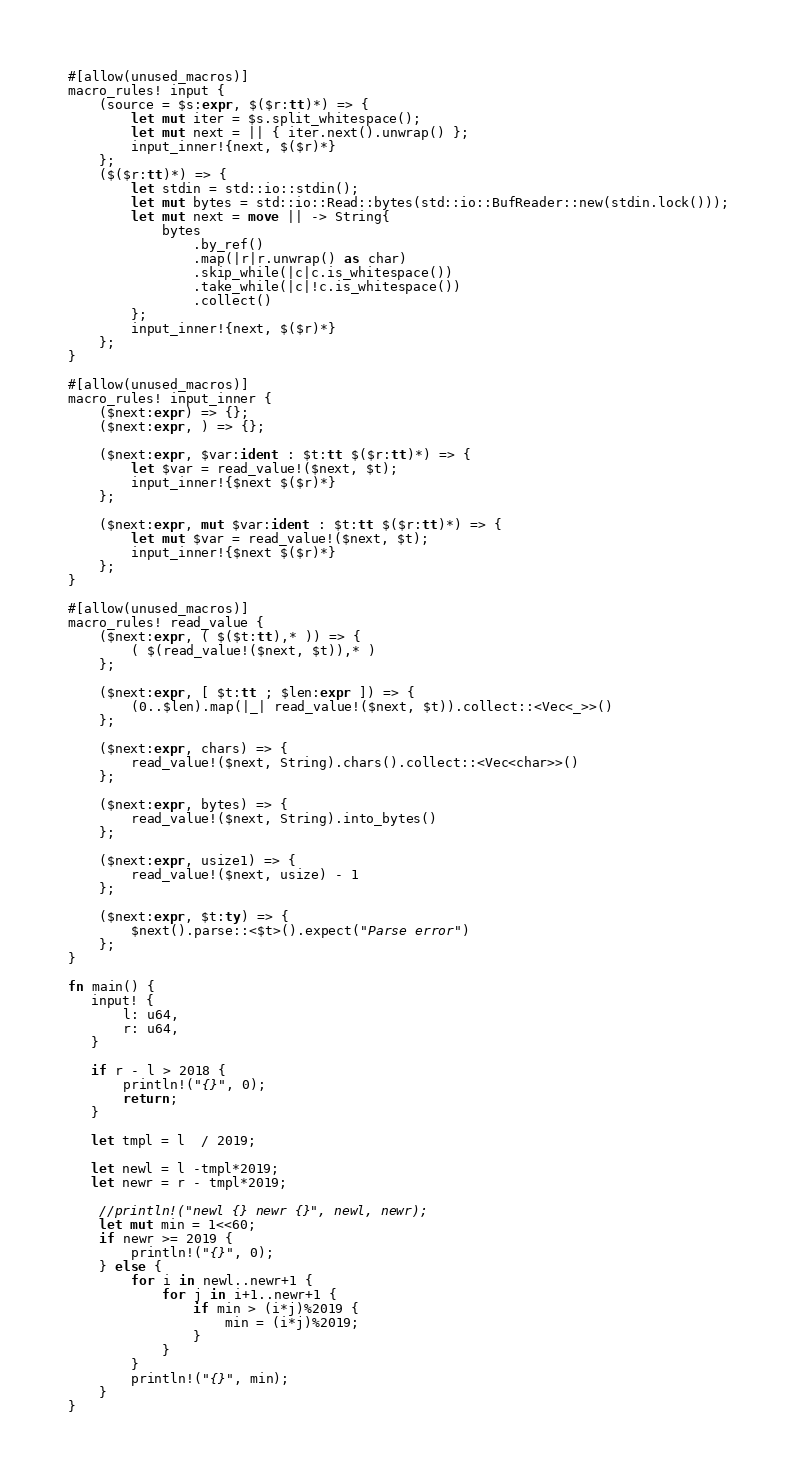<code> <loc_0><loc_0><loc_500><loc_500><_Rust_>#[allow(unused_macros)]
macro_rules! input {
    (source = $s:expr, $($r:tt)*) => {
        let mut iter = $s.split_whitespace();
        let mut next = || { iter.next().unwrap() };
        input_inner!{next, $($r)*}
    };
    ($($r:tt)*) => {
        let stdin = std::io::stdin();
        let mut bytes = std::io::Read::bytes(std::io::BufReader::new(stdin.lock()));
        let mut next = move || -> String{
            bytes
                .by_ref()
                .map(|r|r.unwrap() as char)
                .skip_while(|c|c.is_whitespace())
                .take_while(|c|!c.is_whitespace())
                .collect()
        };
        input_inner!{next, $($r)*}
    };
}
 
#[allow(unused_macros)]
macro_rules! input_inner {
    ($next:expr) => {};
    ($next:expr, ) => {};
 
    ($next:expr, $var:ident : $t:tt $($r:tt)*) => {
        let $var = read_value!($next, $t);
        input_inner!{$next $($r)*}
    };
 
    ($next:expr, mut $var:ident : $t:tt $($r:tt)*) => {
        let mut $var = read_value!($next, $t);
        input_inner!{$next $($r)*}
    };
}
 
#[allow(unused_macros)]
macro_rules! read_value {
    ($next:expr, ( $($t:tt),* )) => {
        ( $(read_value!($next, $t)),* )
    };
 
    ($next:expr, [ $t:tt ; $len:expr ]) => {
        (0..$len).map(|_| read_value!($next, $t)).collect::<Vec<_>>()
    };
 
    ($next:expr, chars) => {
        read_value!($next, String).chars().collect::<Vec<char>>()
    };
 
    ($next:expr, bytes) => {
        read_value!($next, String).into_bytes()
    };
 
    ($next:expr, usize1) => {
        read_value!($next, usize) - 1
    };
 
    ($next:expr, $t:ty) => {
        $next().parse::<$t>().expect("Parse error")
    };
}

fn main() {
   input! {
       l: u64,
       r: u64,
   } 

   if r - l > 2018 {
       println!("{}", 0);
       return;
   }

   let tmpl = l  / 2019;
   
   let newl = l -tmpl*2019;
   let newr = r - tmpl*2019;

    //println!("newl {} newr {}", newl, newr);
    let mut min = 1<<60;
    if newr >= 2019 {
        println!("{}", 0);
    } else {
        for i in newl..newr+1 {
            for j in i+1..newr+1 {
                if min > (i*j)%2019 {
                    min = (i*j)%2019;
                }
            }
        }
        println!("{}", min);
    }
}   

</code> 